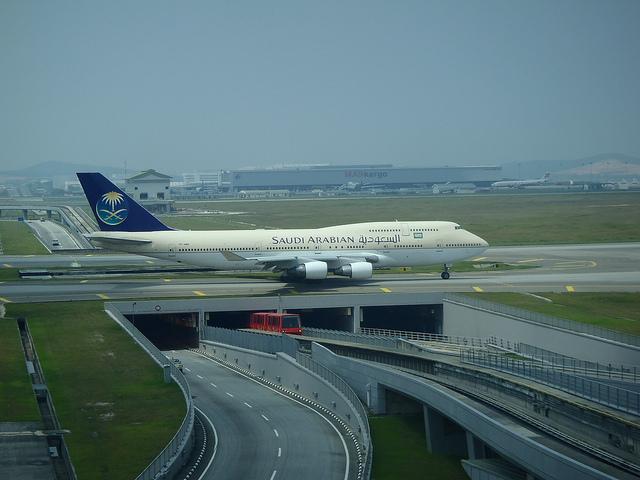How many ski poles are being raised?
Give a very brief answer. 0. 